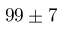<formula> <loc_0><loc_0><loc_500><loc_500>9 9 \pm 7</formula> 